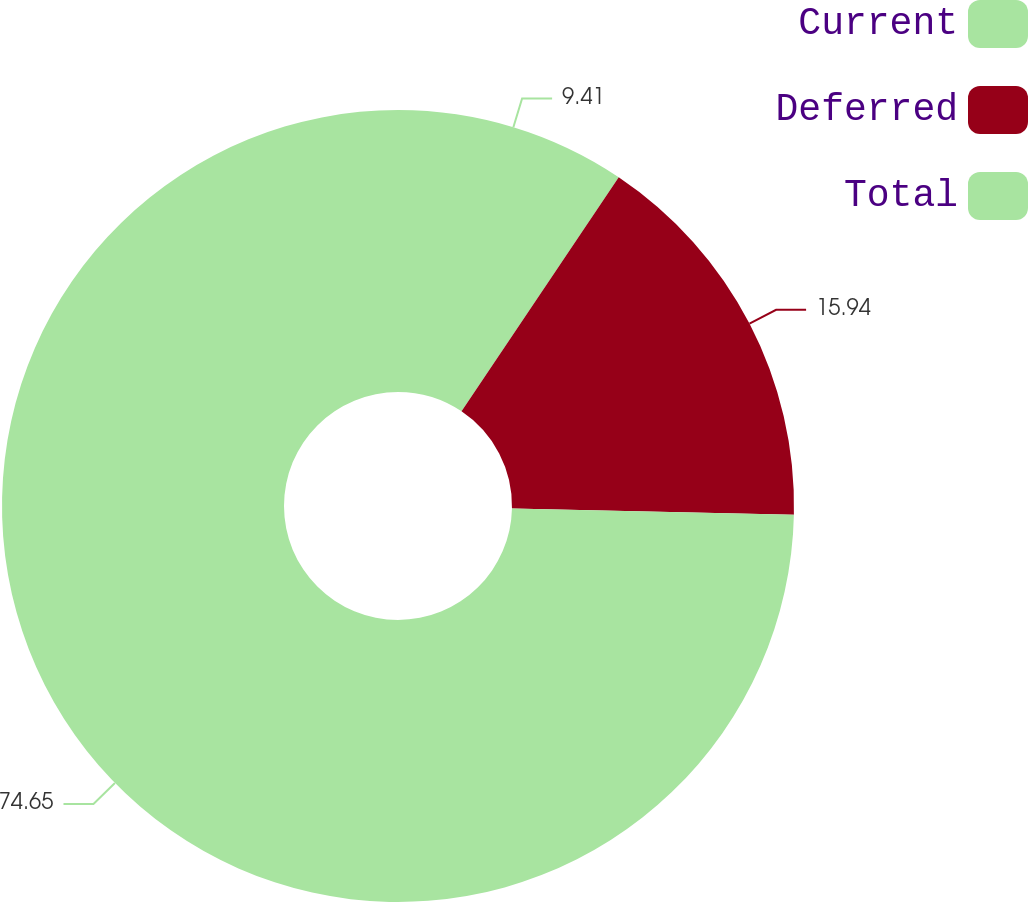Convert chart. <chart><loc_0><loc_0><loc_500><loc_500><pie_chart><fcel>Current<fcel>Deferred<fcel>Total<nl><fcel>9.41%<fcel>15.94%<fcel>74.65%<nl></chart> 